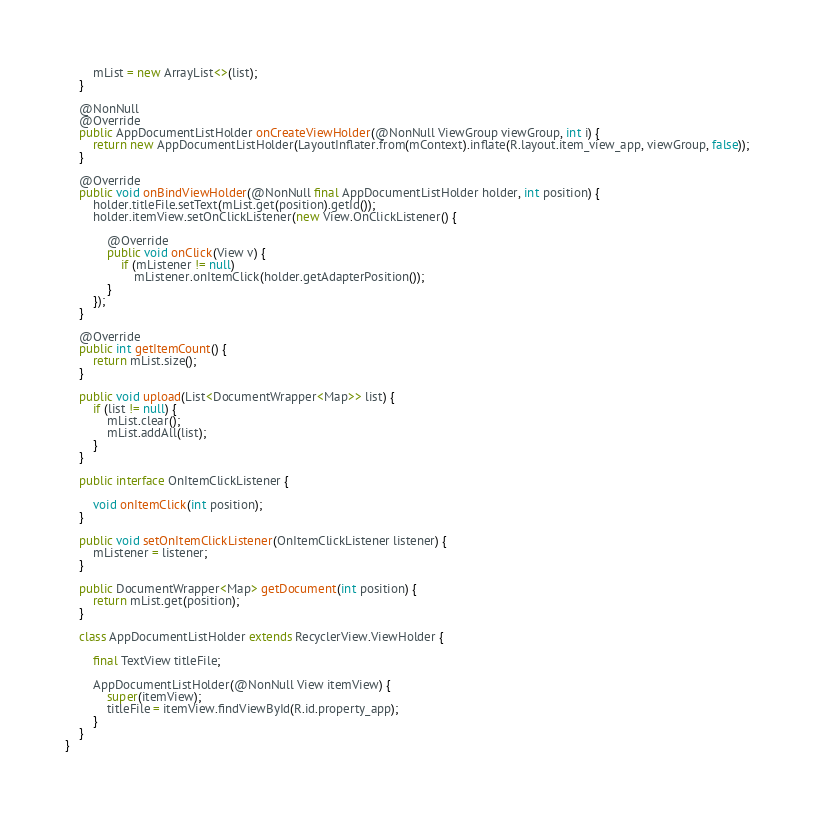<code> <loc_0><loc_0><loc_500><loc_500><_Java_>        mList = new ArrayList<>(list);
    }

    @NonNull
    @Override
    public AppDocumentListHolder onCreateViewHolder(@NonNull ViewGroup viewGroup, int i) {
        return new AppDocumentListHolder(LayoutInflater.from(mContext).inflate(R.layout.item_view_app, viewGroup, false));
    }

    @Override
    public void onBindViewHolder(@NonNull final AppDocumentListHolder holder, int position) {
        holder.titleFile.setText(mList.get(position).getId());
        holder.itemView.setOnClickListener(new View.OnClickListener() {

            @Override
            public void onClick(View v) {
                if (mListener != null)
                    mListener.onItemClick(holder.getAdapterPosition());
            }
        });
    }

    @Override
    public int getItemCount() {
        return mList.size();
    }

    public void upload(List<DocumentWrapper<Map>> list) {
        if (list != null) {
            mList.clear();
            mList.addAll(list);
        }
    }

    public interface OnItemClickListener {

        void onItemClick(int position);
    }

    public void setOnItemClickListener(OnItemClickListener listener) {
        mListener = listener;
    }

    public DocumentWrapper<Map> getDocument(int position) {
        return mList.get(position);
    }

    class AppDocumentListHolder extends RecyclerView.ViewHolder {

        final TextView titleFile;

        AppDocumentListHolder(@NonNull View itemView) {
            super(itemView);
            titleFile = itemView.findViewById(R.id.property_app);
        }
    }
}
</code> 